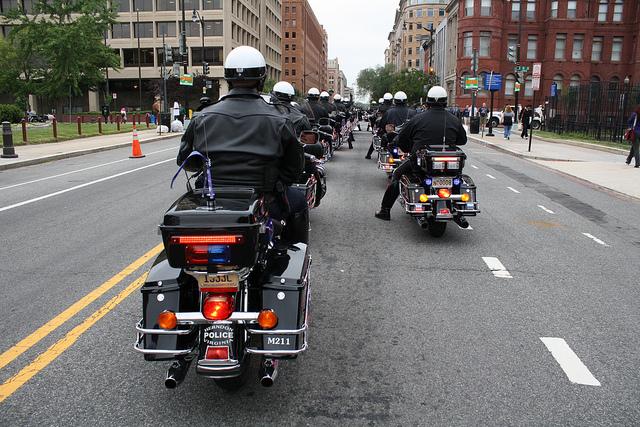Who are at the sidewalks?
Write a very short answer. Pedestrians. What is the profession of the riders?
Answer briefly. Police. Does this group of helmeted riders appear to go on forever?
Short answer required. Yes. 